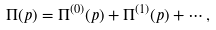Convert formula to latex. <formula><loc_0><loc_0><loc_500><loc_500>\Pi ( p ) = \Pi ^ { ( 0 ) } ( p ) + \Pi ^ { ( 1 ) } ( p ) + \cdots ,</formula> 